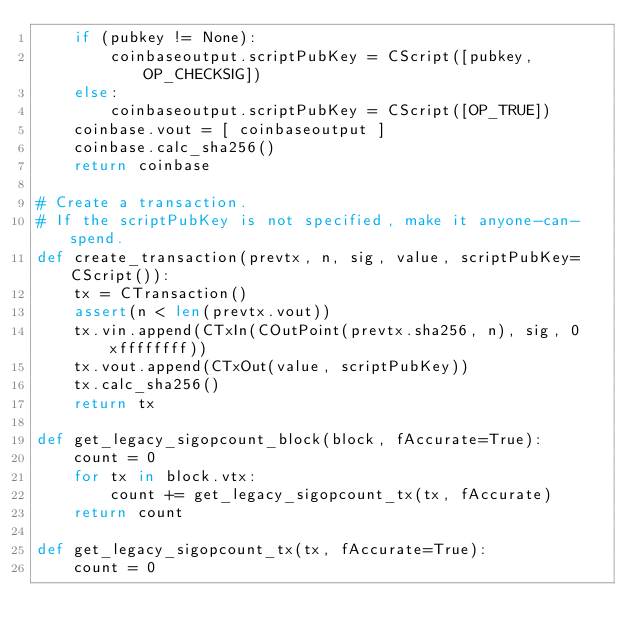Convert code to text. <code><loc_0><loc_0><loc_500><loc_500><_Python_>    if (pubkey != None):
        coinbaseoutput.scriptPubKey = CScript([pubkey, OP_CHECKSIG])
    else:
        coinbaseoutput.scriptPubKey = CScript([OP_TRUE])
    coinbase.vout = [ coinbaseoutput ]
    coinbase.calc_sha256()
    return coinbase

# Create a transaction.
# If the scriptPubKey is not specified, make it anyone-can-spend.
def create_transaction(prevtx, n, sig, value, scriptPubKey=CScript()):
    tx = CTransaction()
    assert(n < len(prevtx.vout))
    tx.vin.append(CTxIn(COutPoint(prevtx.sha256, n), sig, 0xffffffff))
    tx.vout.append(CTxOut(value, scriptPubKey))
    tx.calc_sha256()
    return tx

def get_legacy_sigopcount_block(block, fAccurate=True):
    count = 0
    for tx in block.vtx:
        count += get_legacy_sigopcount_tx(tx, fAccurate)
    return count

def get_legacy_sigopcount_tx(tx, fAccurate=True):
    count = 0</code> 